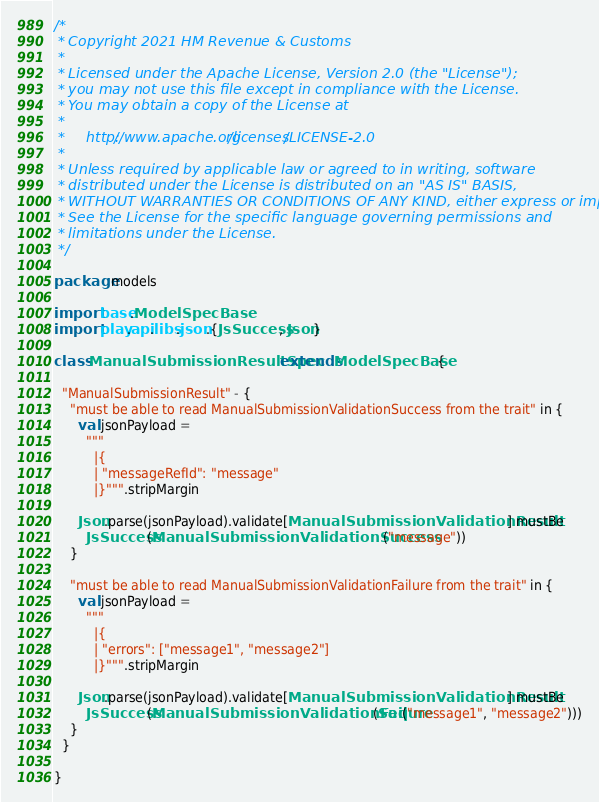<code> <loc_0><loc_0><loc_500><loc_500><_Scala_>/*
 * Copyright 2021 HM Revenue & Customs
 *
 * Licensed under the Apache License, Version 2.0 (the "License");
 * you may not use this file except in compliance with the License.
 * You may obtain a copy of the License at
 *
 *     http://www.apache.org/licenses/LICENSE-2.0
 *
 * Unless required by applicable law or agreed to in writing, software
 * distributed under the License is distributed on an "AS IS" BASIS,
 * WITHOUT WARRANTIES OR CONDITIONS OF ANY KIND, either express or implied.
 * See the License for the specific language governing permissions and
 * limitations under the License.
 */

package models

import base.ModelSpecBase
import play.api.libs.json.{JsSuccess, Json}

class ManualSubmissionResultSpec extends ModelSpecBase {

  "ManualSubmissionResult" - {
    "must be able to read ManualSubmissionValidationSuccess from the trait" in {
      val jsonPayload =
        """
          |{
          | "messageRefId": "message"
          |}""".stripMargin

      Json.parse(jsonPayload).validate[ManualSubmissionValidationResult] mustBe
        JsSuccess(ManualSubmissionValidationSuccess("message"))
    }

    "must be able to read ManualSubmissionValidationFailure from the trait" in {
      val jsonPayload =
        """
          |{
          | "errors": ["message1", "message2"]
          |}""".stripMargin

      Json.parse(jsonPayload).validate[ManualSubmissionValidationResult] mustBe
        JsSuccess(ManualSubmissionValidationFailure(Seq("message1", "message2")))
    }
  }

}
</code> 